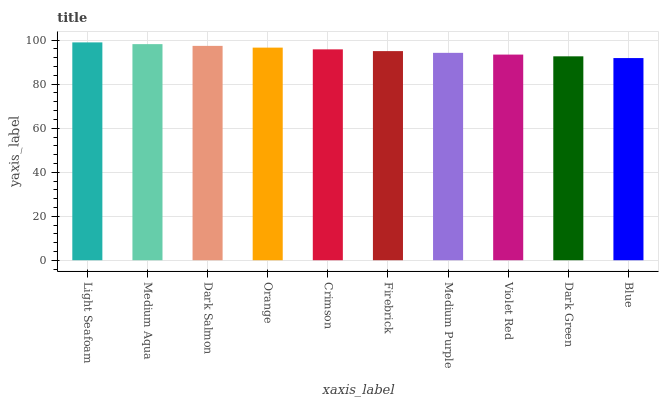Is Blue the minimum?
Answer yes or no. Yes. Is Light Seafoam the maximum?
Answer yes or no. Yes. Is Medium Aqua the minimum?
Answer yes or no. No. Is Medium Aqua the maximum?
Answer yes or no. No. Is Light Seafoam greater than Medium Aqua?
Answer yes or no. Yes. Is Medium Aqua less than Light Seafoam?
Answer yes or no. Yes. Is Medium Aqua greater than Light Seafoam?
Answer yes or no. No. Is Light Seafoam less than Medium Aqua?
Answer yes or no. No. Is Crimson the high median?
Answer yes or no. Yes. Is Firebrick the low median?
Answer yes or no. Yes. Is Firebrick the high median?
Answer yes or no. No. Is Violet Red the low median?
Answer yes or no. No. 